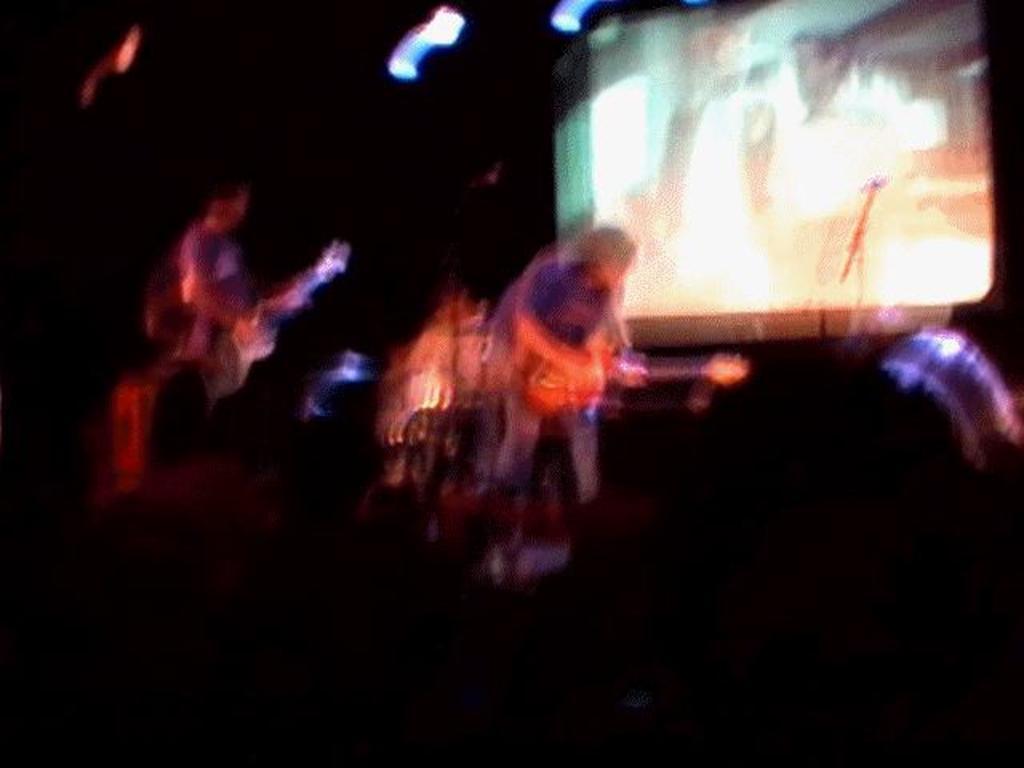How would you summarize this image in a sentence or two? The image is blurred. The image consists of a band performing, we can see people playing guitars. In the background there is a screen. 